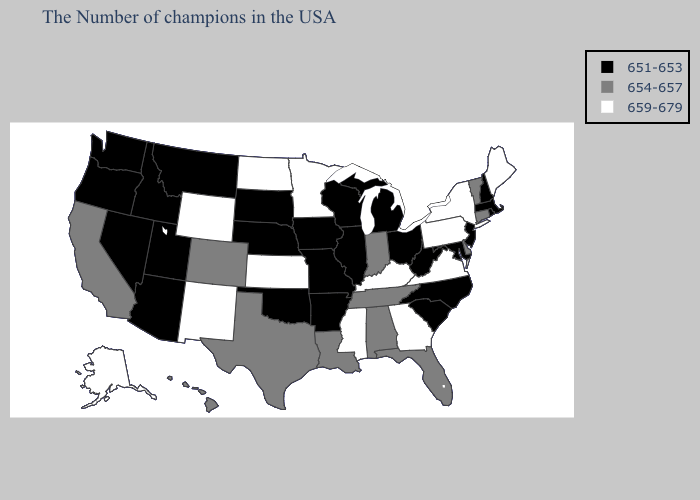Does West Virginia have the same value as Utah?
Be succinct. Yes. Does Idaho have the highest value in the USA?
Quick response, please. No. Name the states that have a value in the range 651-653?
Short answer required. Massachusetts, Rhode Island, New Hampshire, New Jersey, Maryland, North Carolina, South Carolina, West Virginia, Ohio, Michigan, Wisconsin, Illinois, Missouri, Arkansas, Iowa, Nebraska, Oklahoma, South Dakota, Utah, Montana, Arizona, Idaho, Nevada, Washington, Oregon. Does Michigan have the highest value in the USA?
Answer briefly. No. What is the lowest value in the Northeast?
Write a very short answer. 651-653. What is the value of Missouri?
Concise answer only. 651-653. Name the states that have a value in the range 659-679?
Short answer required. Maine, New York, Pennsylvania, Virginia, Georgia, Kentucky, Mississippi, Minnesota, Kansas, North Dakota, Wyoming, New Mexico, Alaska. Does Mississippi have a higher value than Pennsylvania?
Quick response, please. No. Does Louisiana have the same value as Alaska?
Give a very brief answer. No. What is the value of Mississippi?
Short answer required. 659-679. Name the states that have a value in the range 659-679?
Quick response, please. Maine, New York, Pennsylvania, Virginia, Georgia, Kentucky, Mississippi, Minnesota, Kansas, North Dakota, Wyoming, New Mexico, Alaska. Does the first symbol in the legend represent the smallest category?
Write a very short answer. Yes. What is the lowest value in the USA?
Answer briefly. 651-653. Does Indiana have the lowest value in the USA?
Answer briefly. No. What is the highest value in the Northeast ?
Write a very short answer. 659-679. 